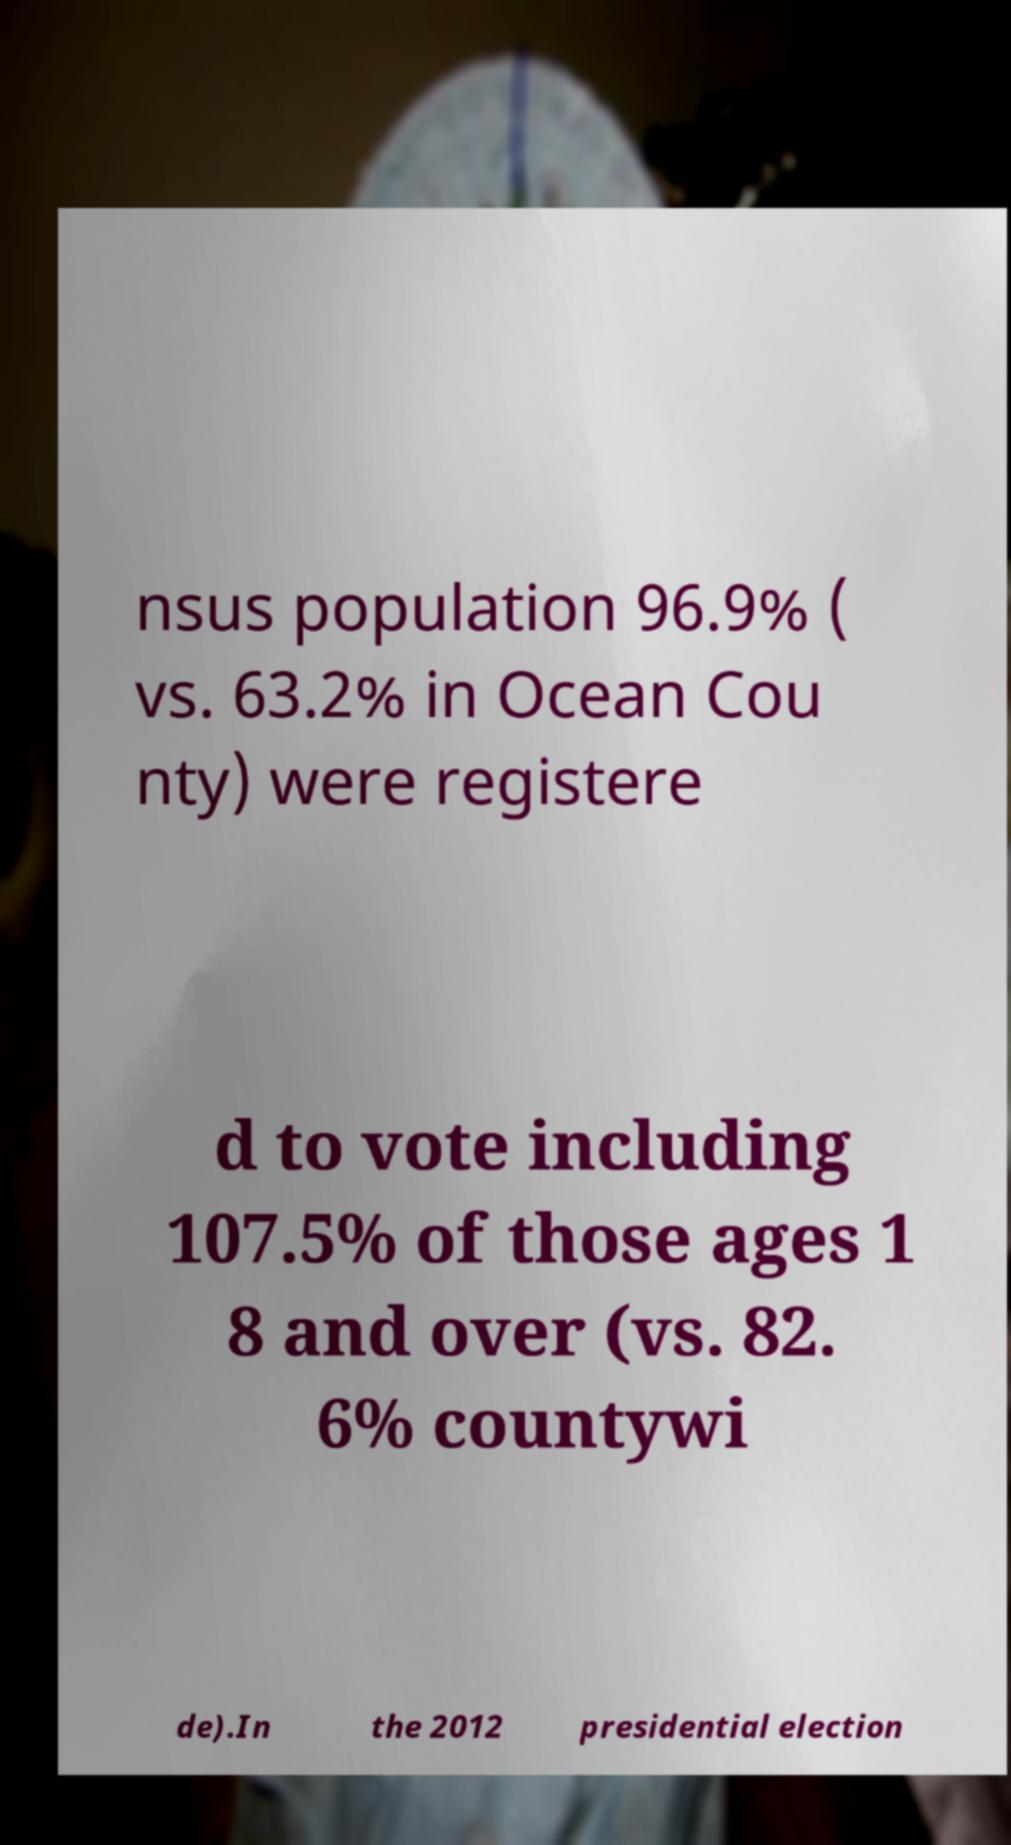I need the written content from this picture converted into text. Can you do that? nsus population 96.9% ( vs. 63.2% in Ocean Cou nty) were registere d to vote including 107.5% of those ages 1 8 and over (vs. 82. 6% countywi de).In the 2012 presidential election 